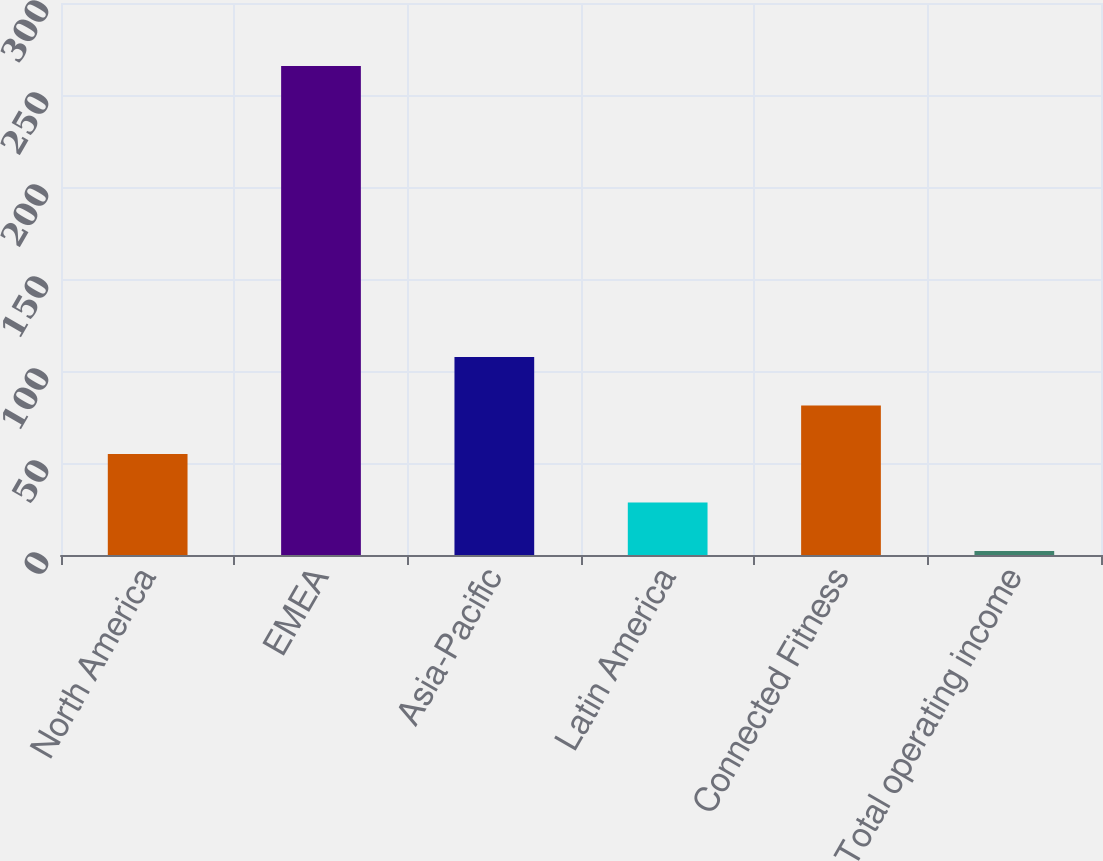<chart> <loc_0><loc_0><loc_500><loc_500><bar_chart><fcel>North America<fcel>EMEA<fcel>Asia-Pacific<fcel>Latin America<fcel>Connected Fitness<fcel>Total operating income<nl><fcel>54.92<fcel>265.8<fcel>107.64<fcel>28.56<fcel>81.28<fcel>2.2<nl></chart> 